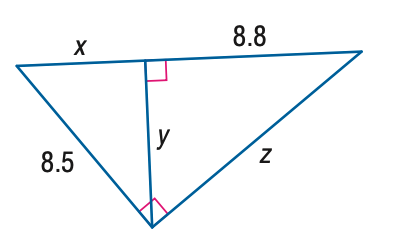Answer the mathemtical geometry problem and directly provide the correct option letter.
Question: Refer to the figure at the right. Find z.
Choices: A: 8.80 B: 9.58 C: 11.09 D: 13.11 C 